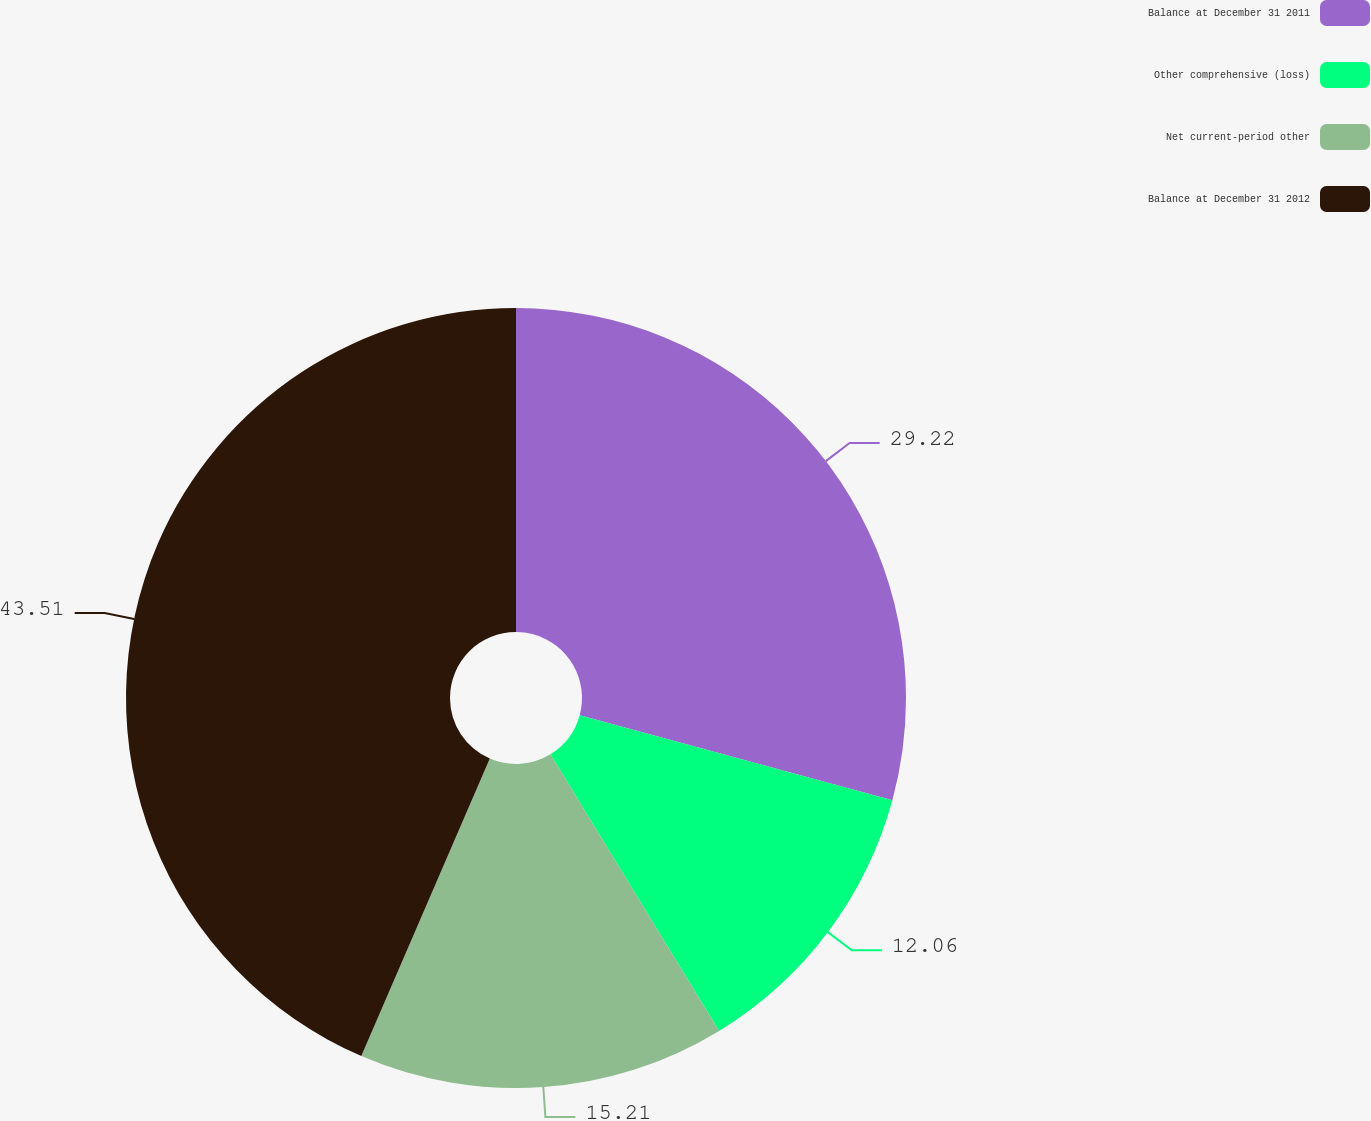<chart> <loc_0><loc_0><loc_500><loc_500><pie_chart><fcel>Balance at December 31 2011<fcel>Other comprehensive (loss)<fcel>Net current-period other<fcel>Balance at December 31 2012<nl><fcel>29.22%<fcel>12.06%<fcel>15.21%<fcel>43.51%<nl></chart> 